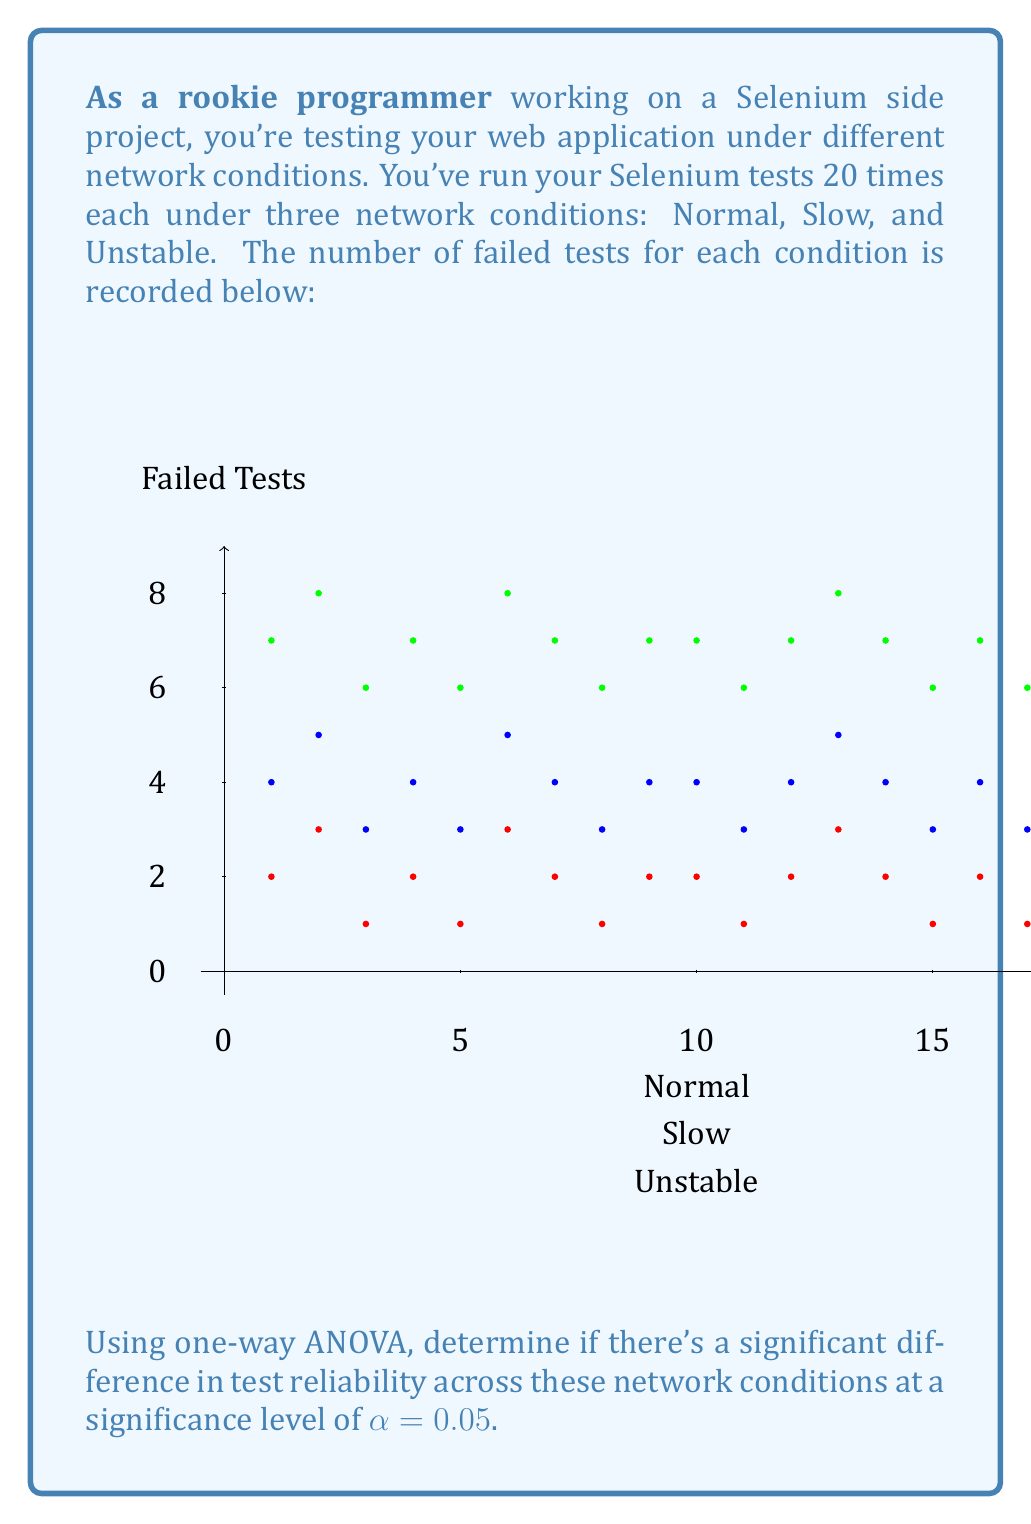Give your solution to this math problem. Let's approach this step-by-step:

1) First, we need to calculate the sum of squares:

   $$SS_{total} = \sum_{i=1}^{n} (x_i - \bar{x})^2$$
   $$SS_{between} = \sum_{i=1}^{k} n_i(\bar{x}_i - \bar{x})^2$$
   $$SS_{within} = SS_{total} - SS_{between}$$

2) Calculate the means for each group and the overall mean:
   Normal: $\bar{x}_1 = 1.85$
   Slow: $\bar{x}_2 = 3.85$
   Unstable: $\bar{x}_3 = 6.85$
   Overall: $\bar{x} = 4.18333$

3) Calculate $SS_{total}$:
   $$SS_{total} = 453.65$$

4) Calculate $SS_{between}$:
   $$SS_{between} = 20[(1.85 - 4.18333)^2 + (3.85 - 4.18333)^2 + (6.85 - 4.18333)^2] = 375$$

5) Calculate $SS_{within}$:
   $$SS_{within} = 453.65 - 375 = 78.65$$

6) Degrees of freedom:
   $df_{between} = k - 1 = 2$
   $df_{within} = N - k = 57$
   Where k is the number of groups and N is the total number of observations.

7) Mean Square:
   $$MS_{between} = \frac{SS_{between}}{df_{between}} = \frac{375}{2} = 187.5$$
   $$MS_{within} = \frac{SS_{within}}{df_{within}} = \frac{78.65}{57} = 1.38$$

8) F-statistic:
   $$F = \frac{MS_{between}}{MS_{within}} = \frac{187.5}{1.38} = 135.87$$

9) The critical F-value for α = 0.05, df₁ = 2, df₂ = 57 is approximately 3.16.

10) Since our calculated F-value (135.87) is greater than the critical F-value (3.16), we reject the null hypothesis.
Answer: Significant difference exists (F(2,57) = 135.87, p < 0.05) 